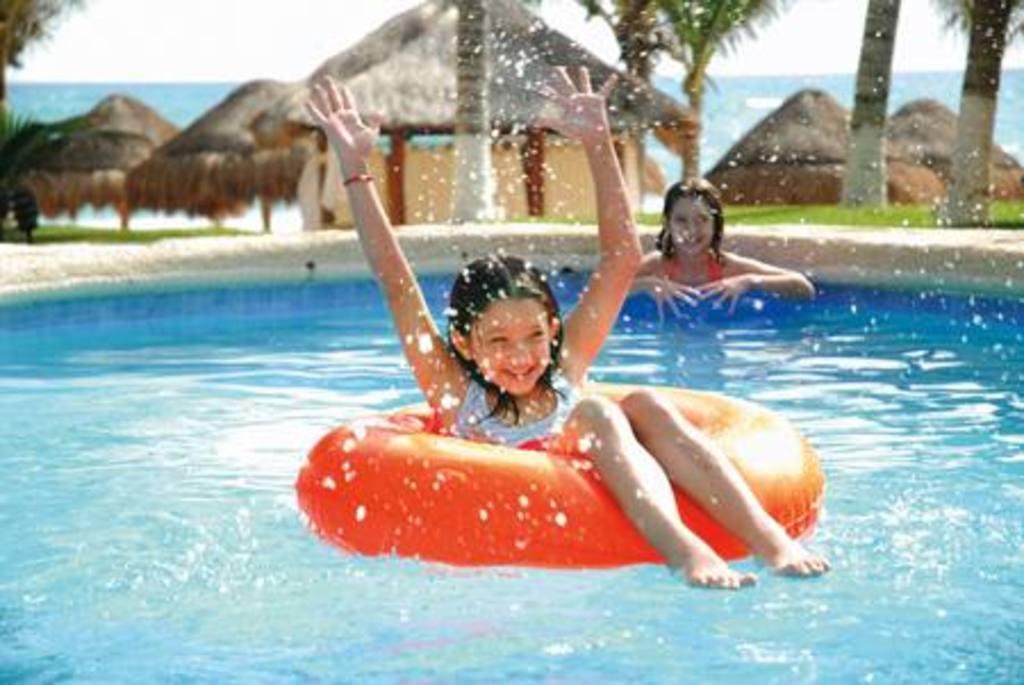Can you describe this image briefly? In this image I can see a swimming pool in the front and in it I can see two girls. I can also see an orange colour tube in the front and in the background I can see few trees and few shacks. 